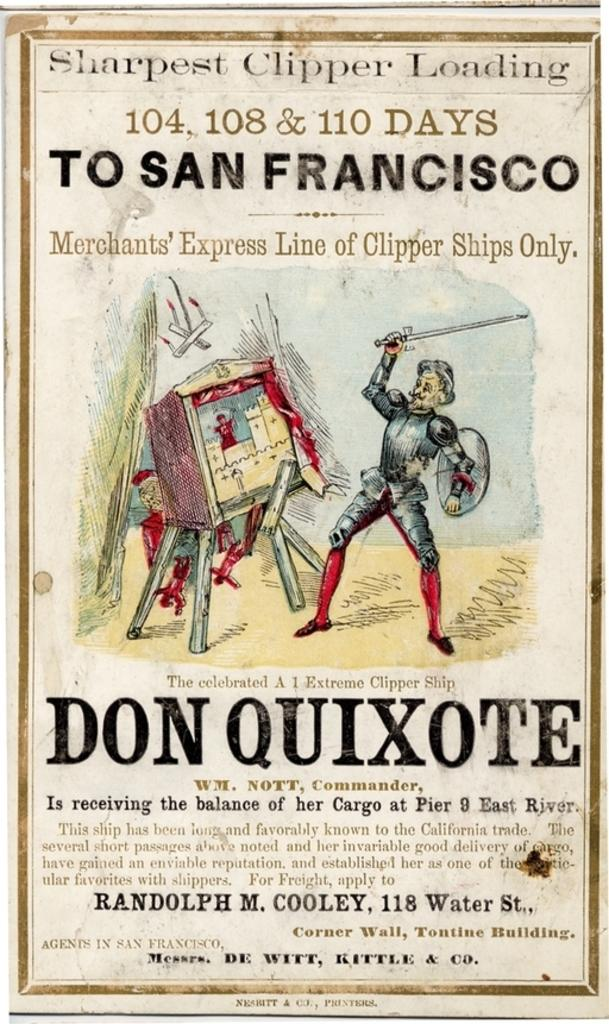<image>
Describe the image concisely. Don Quixote stands wearing a knight's armor holding his sword up in front of a mechanical device. 